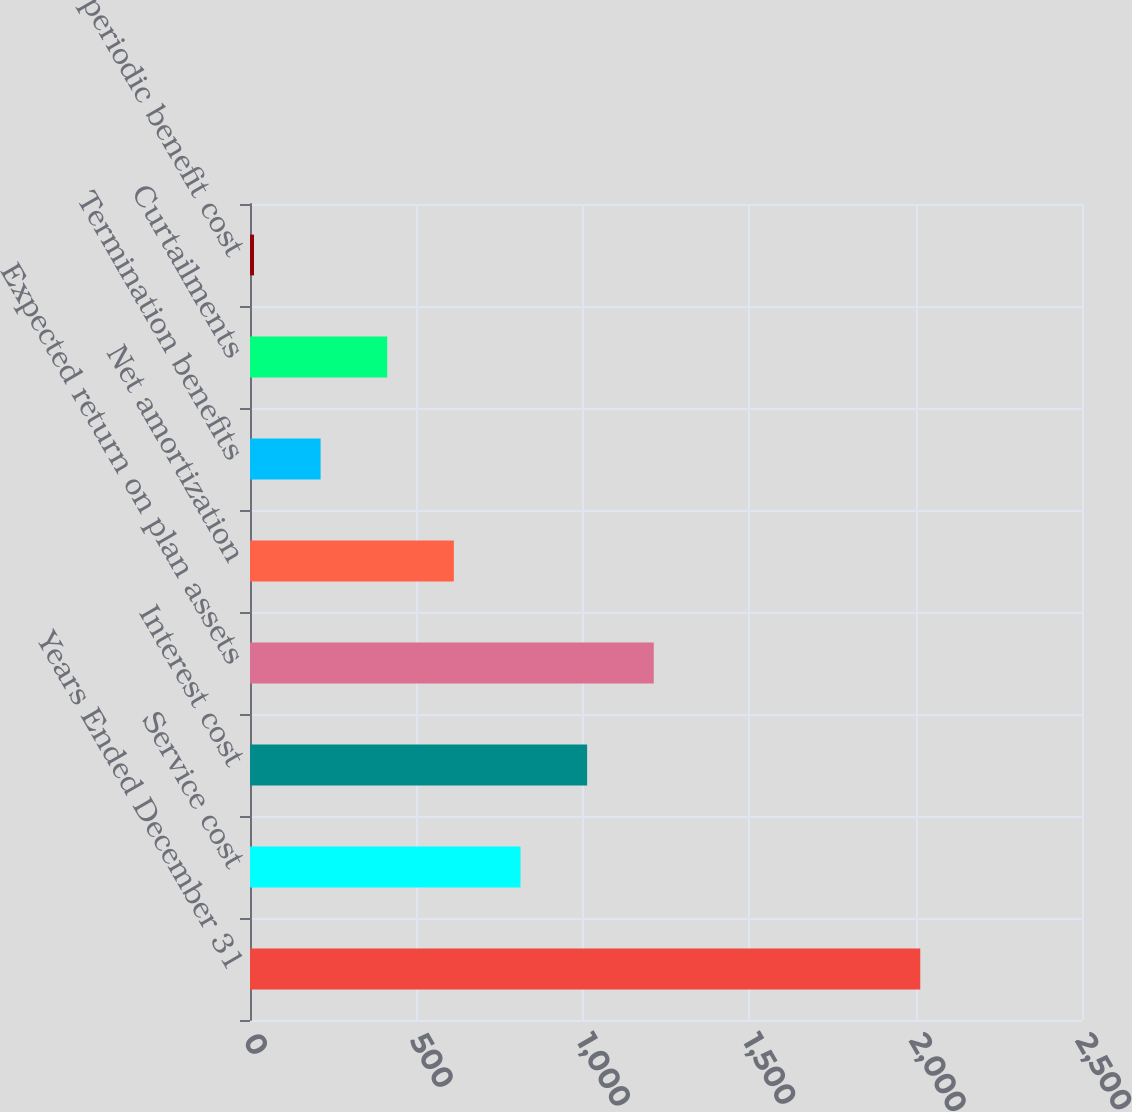<chart> <loc_0><loc_0><loc_500><loc_500><bar_chart><fcel>Years Ended December 31<fcel>Service cost<fcel>Interest cost<fcel>Expected return on plan assets<fcel>Net amortization<fcel>Termination benefits<fcel>Curtailments<fcel>Net periodic benefit cost<nl><fcel>2014<fcel>812.8<fcel>1013<fcel>1213.2<fcel>612.6<fcel>212.2<fcel>412.4<fcel>12<nl></chart> 